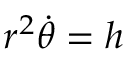Convert formula to latex. <formula><loc_0><loc_0><loc_500><loc_500>r ^ { 2 } { \dot { \theta } } = h</formula> 